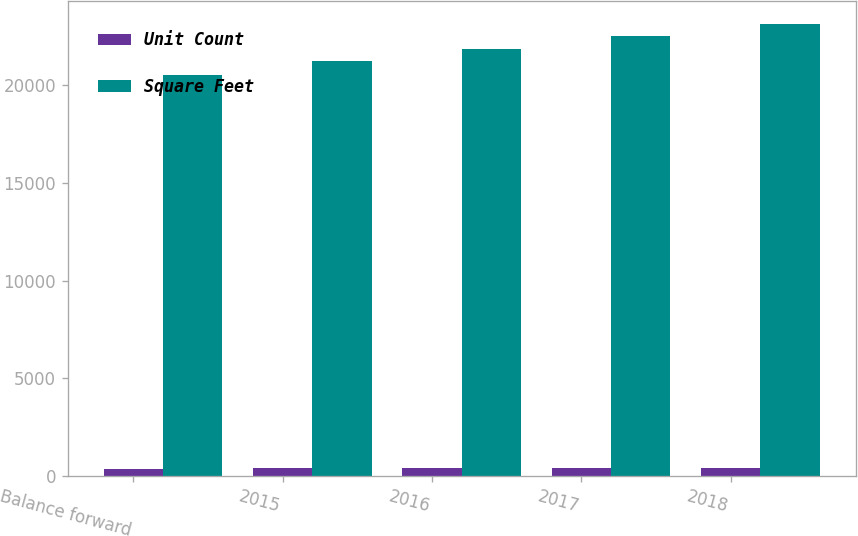<chart> <loc_0><loc_0><loc_500><loc_500><stacked_bar_chart><ecel><fcel>Balance forward<fcel>2015<fcel>2016<fcel>2017<fcel>2018<nl><fcel>Unit Count<fcel>379<fcel>396<fcel>408<fcel>412<fcel>424<nl><fcel>Square Feet<fcel>20513<fcel>21223<fcel>21869<fcel>22542<fcel>23134<nl></chart> 